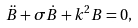Convert formula to latex. <formula><loc_0><loc_0><loc_500><loc_500>\ddot { B } + \sigma \dot { B } + k ^ { 2 } B = 0 ,</formula> 